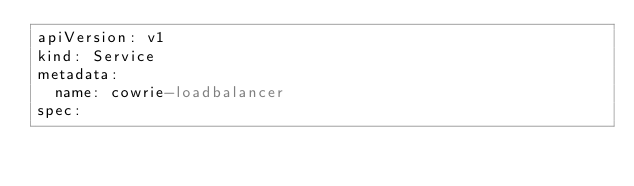Convert code to text. <code><loc_0><loc_0><loc_500><loc_500><_YAML_>apiVersion: v1
kind: Service
metadata:
  name: cowrie-loadbalancer
spec:</code> 